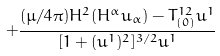Convert formula to latex. <formula><loc_0><loc_0><loc_500><loc_500>+ { \frac { { ( \mu / 4 \pi ) H ^ { 2 } ( H ^ { \alpha } u _ { \alpha } ) - T _ { ( 0 ) } ^ { 1 2 } u ^ { 1 } } } { { [ 1 + ( u ^ { 1 } ) ^ { 2 } ] ^ { 3 / 2 } u ^ { 1 } } } }</formula> 